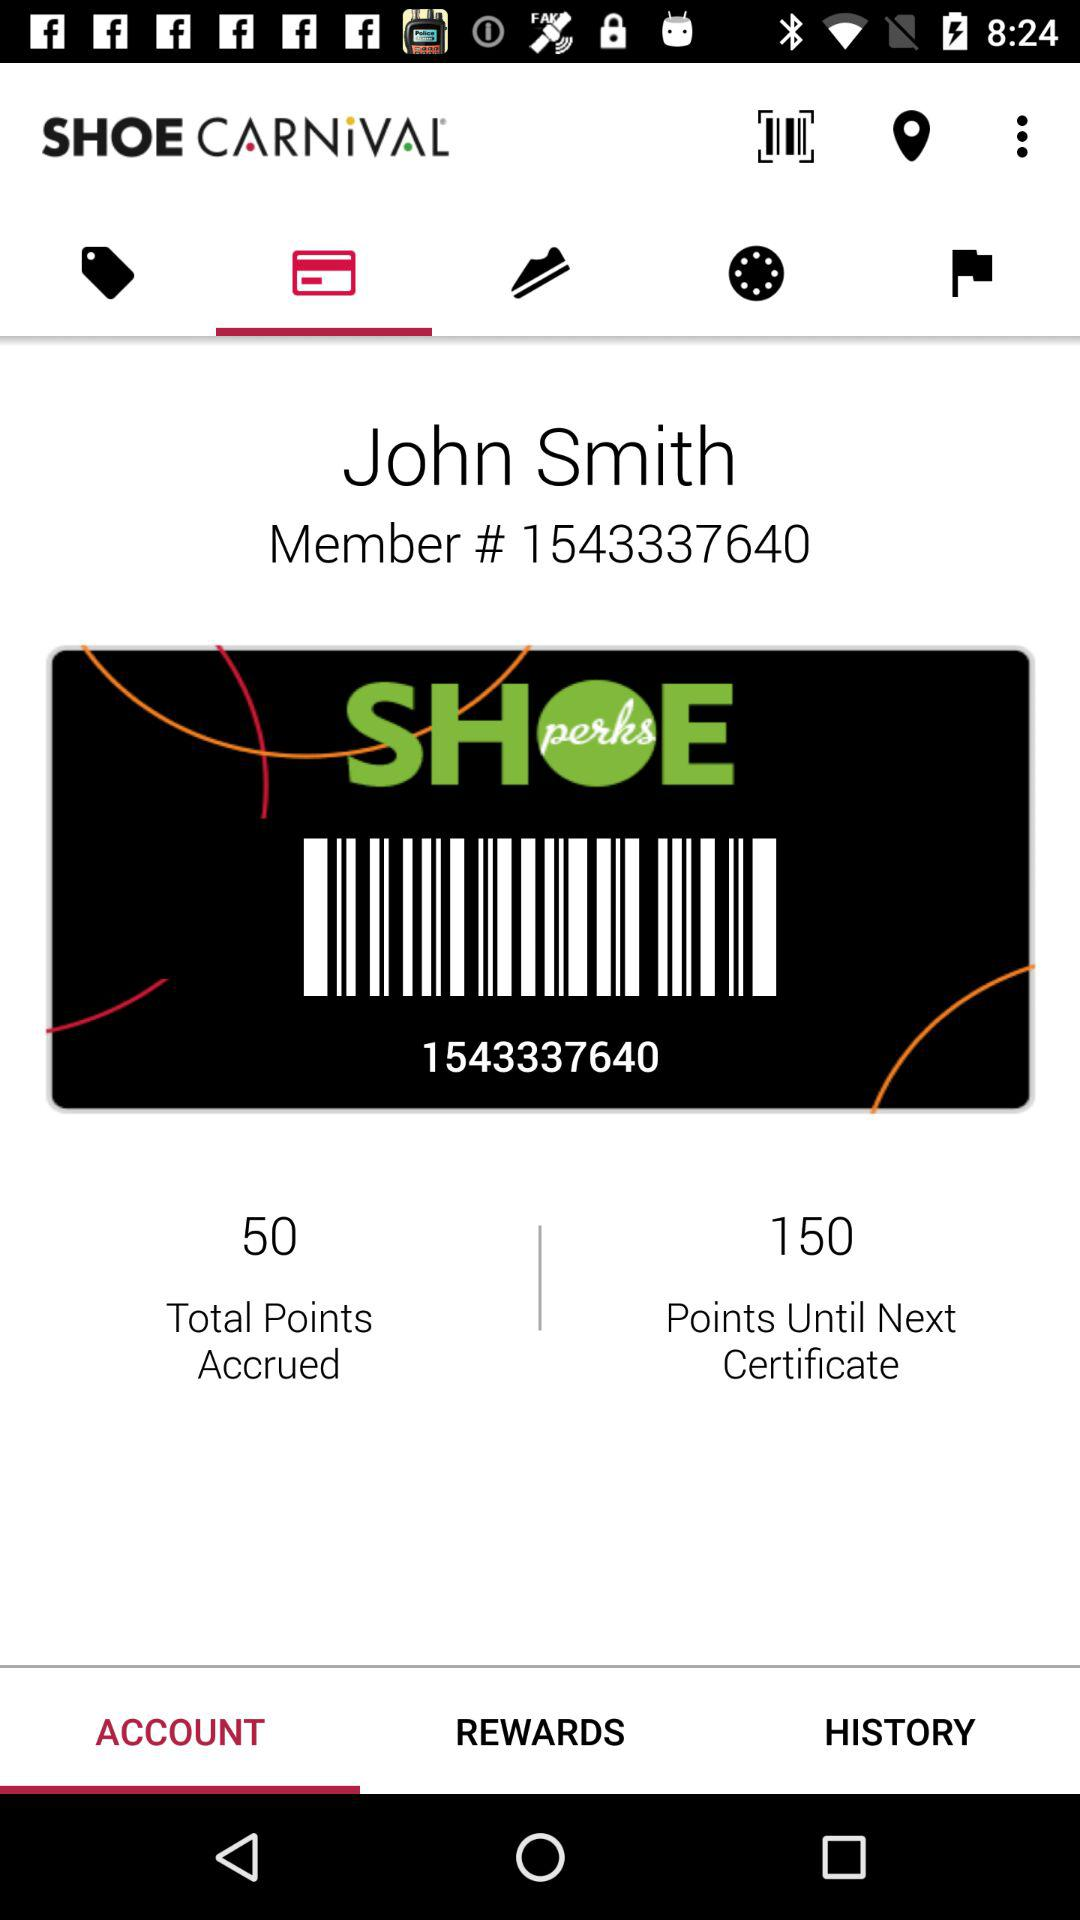What is the name of the user? The name of the user is John Smith. 